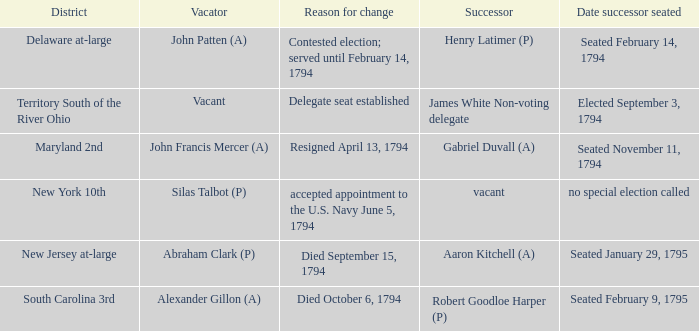Identify the date on which the successor assumed their position following the contested election, holding the position until february 14, 1794. Seated February 14, 1794. 